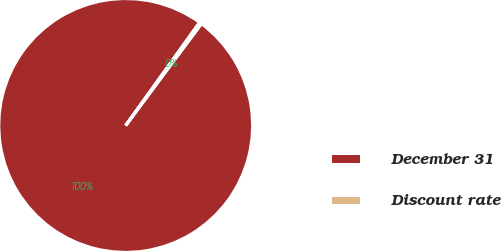Convert chart. <chart><loc_0><loc_0><loc_500><loc_500><pie_chart><fcel>December 31<fcel>Discount rate<nl><fcel>99.72%<fcel>0.28%<nl></chart> 